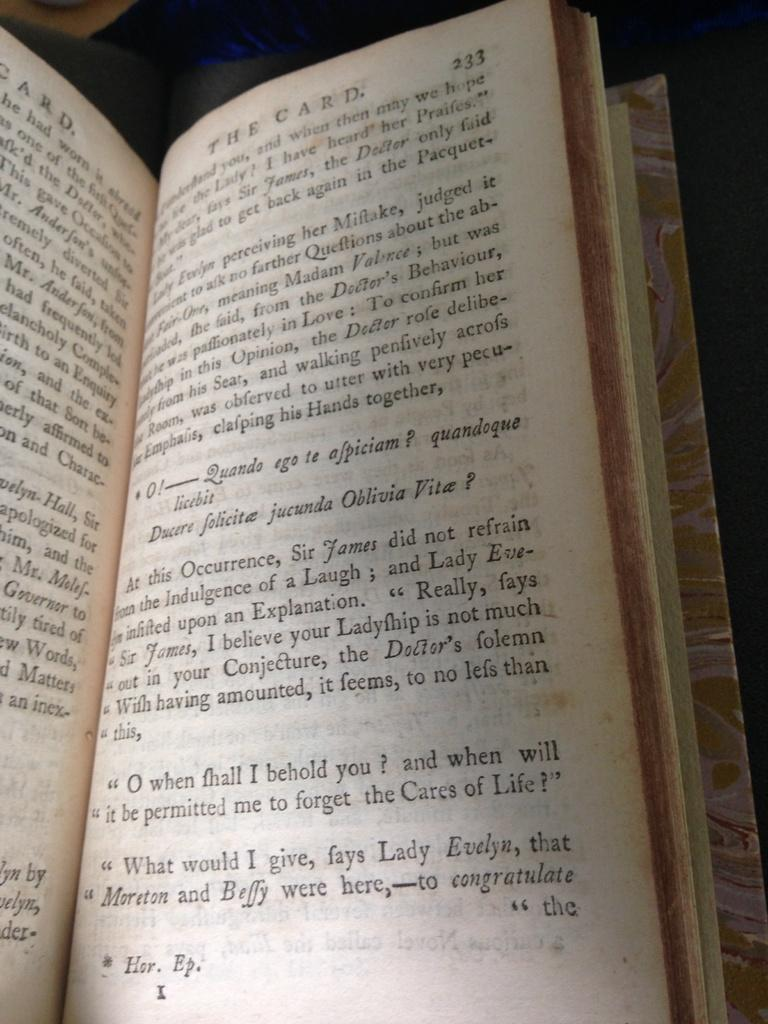<image>
Offer a succinct explanation of the picture presented. an open page of the book The Card at page 233 